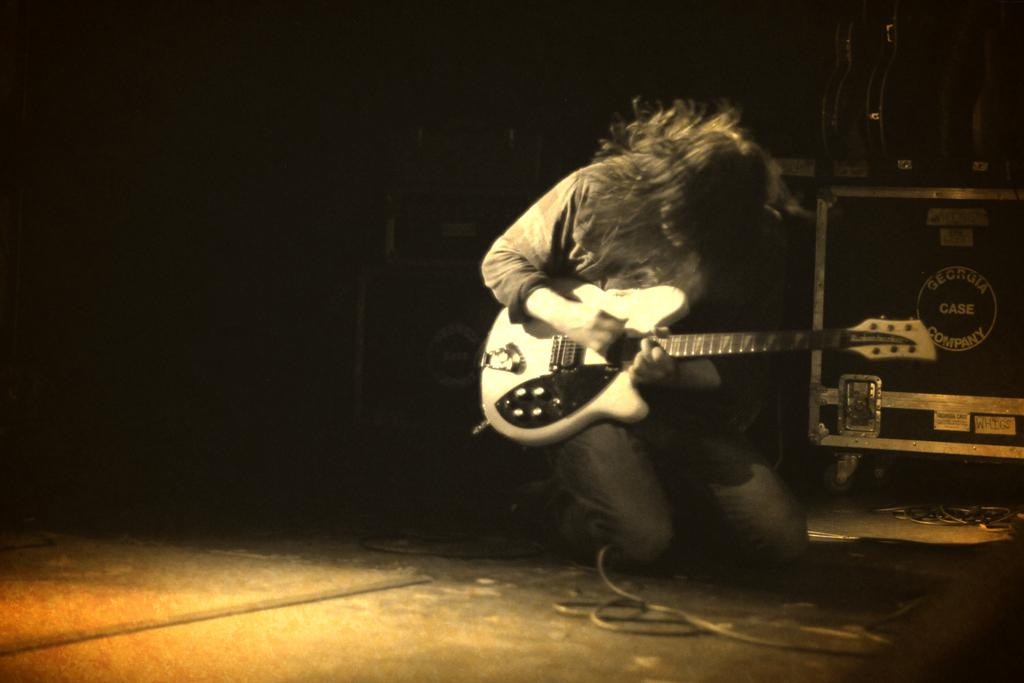What is the main subject of the image? There is a person in the image. What is the person holding in the image? The person is holding a guitar. What type of plot is the person standing on in the image? There is no plot visible in the image; it only shows a person holding a guitar. What kind of paper can be seen on the guitar in the image? There is no paper present on the guitar in the image. 